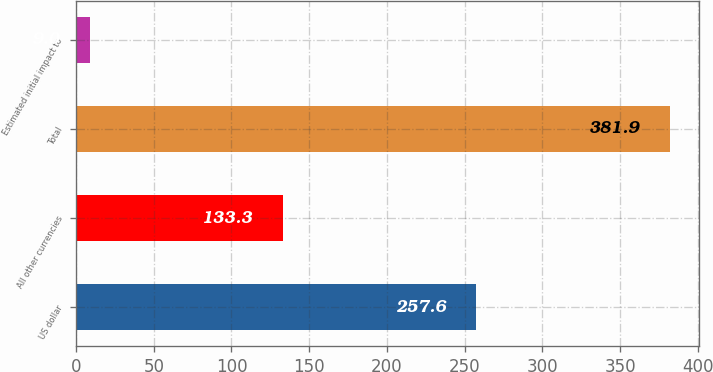Convert chart. <chart><loc_0><loc_0><loc_500><loc_500><bar_chart><fcel>US dollar<fcel>All other currencies<fcel>Total<fcel>Estimated initial impact to<nl><fcel>257.6<fcel>133.3<fcel>381.9<fcel>9<nl></chart> 